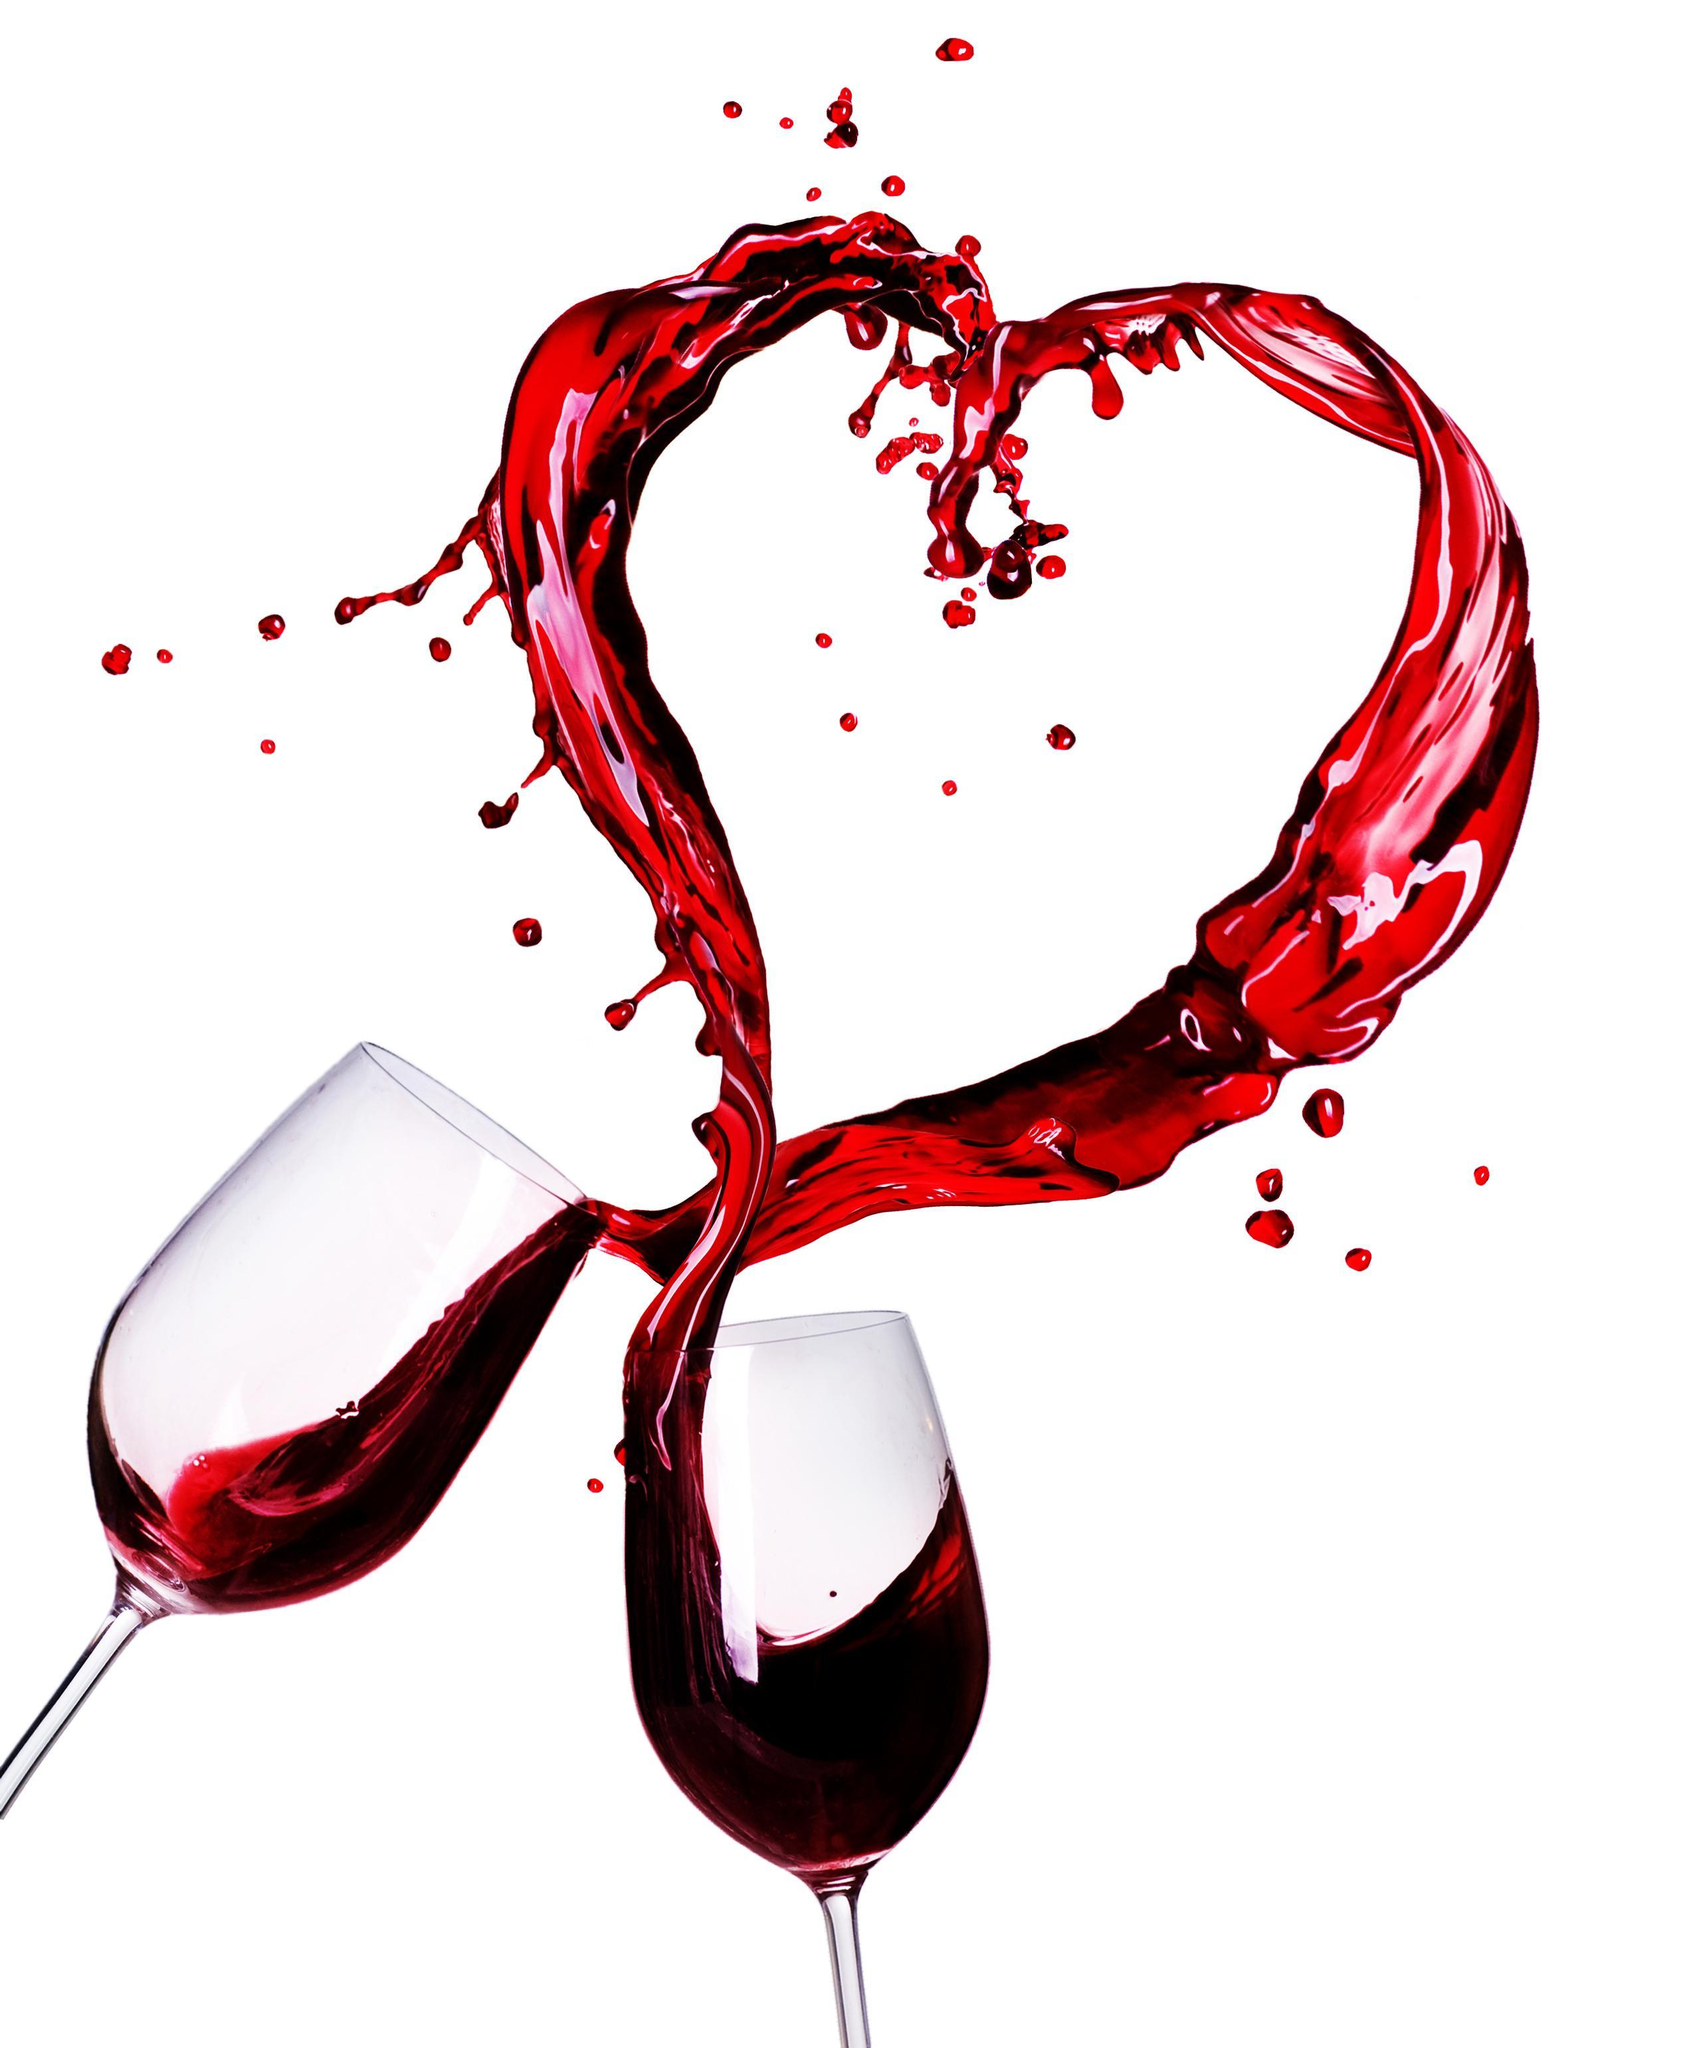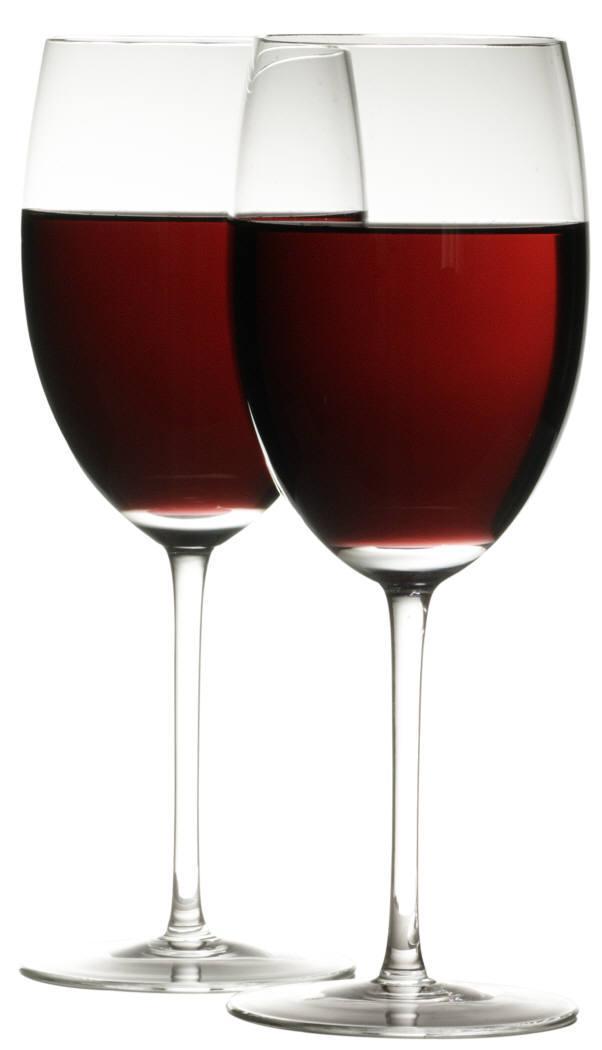The first image is the image on the left, the second image is the image on the right. Analyze the images presented: Is the assertion "Each image contains two wine glasses and no bottles, and left image shows red wine splashing from glasses clinked together." valid? Answer yes or no. Yes. The first image is the image on the left, the second image is the image on the right. Given the left and right images, does the statement "One image shows two glasses of red wine clinking together with wine spilling out and the other image shows only two still glasses of red wine side by side" hold true? Answer yes or no. Yes. 